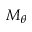Convert formula to latex. <formula><loc_0><loc_0><loc_500><loc_500>M _ { \theta }</formula> 